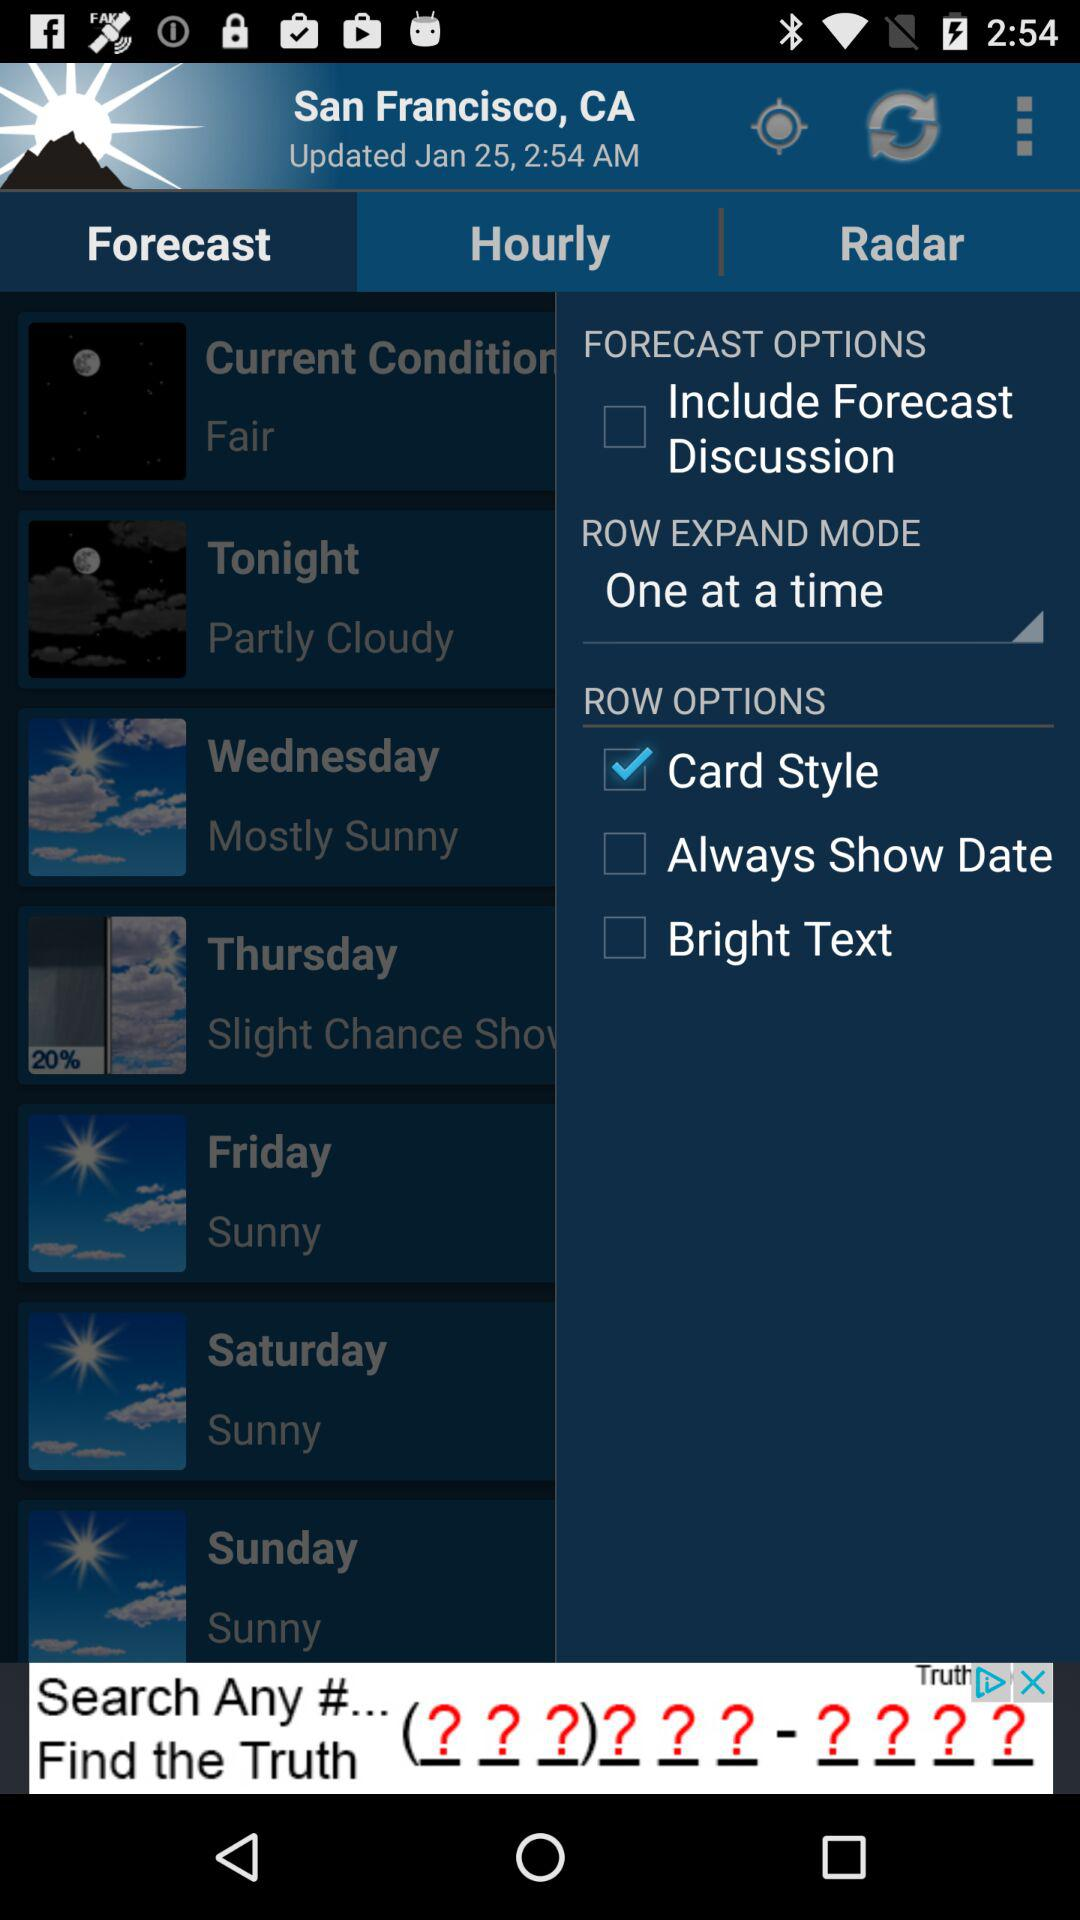Which tab is selected? The selected tab is "Forecast". 